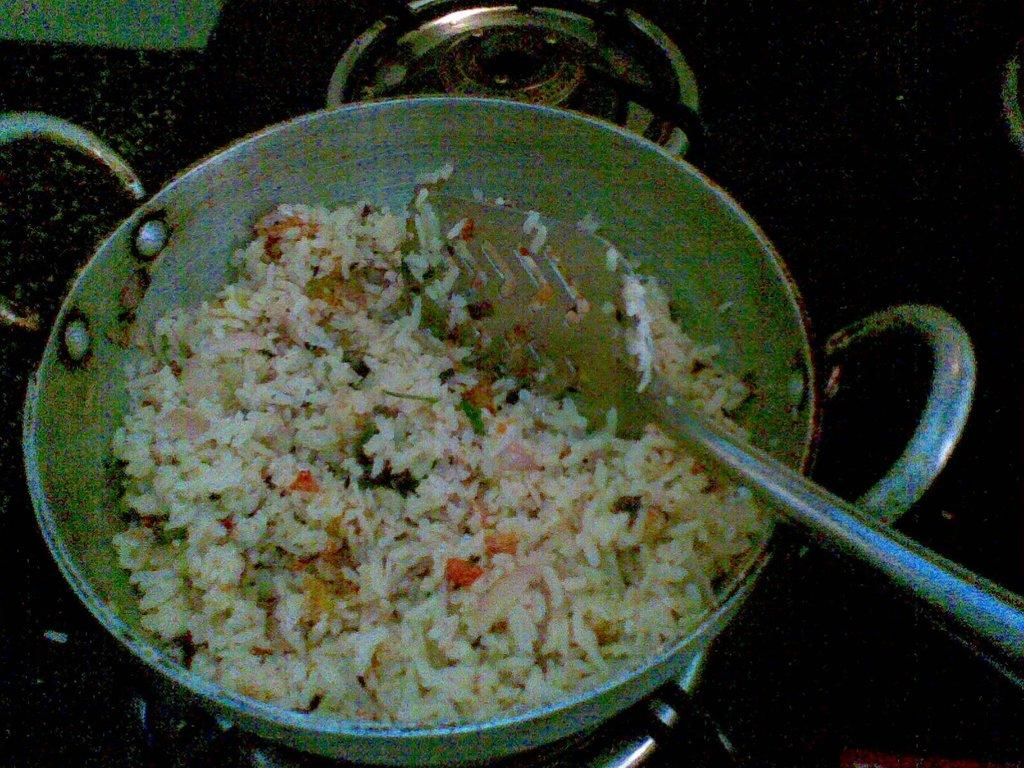What is in the pan that is visible in the image? There is a pan with food in the image. What utensil is on the pan in the image? There is a spatula on the pan. Where is the pan located in the image? The pan is placed on a stove. How many mice are hiding under the pan in the image? There are no mice present in the image; it only shows a pan with food, a spatula, and a stove. 